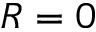<formula> <loc_0><loc_0><loc_500><loc_500>R = 0</formula> 